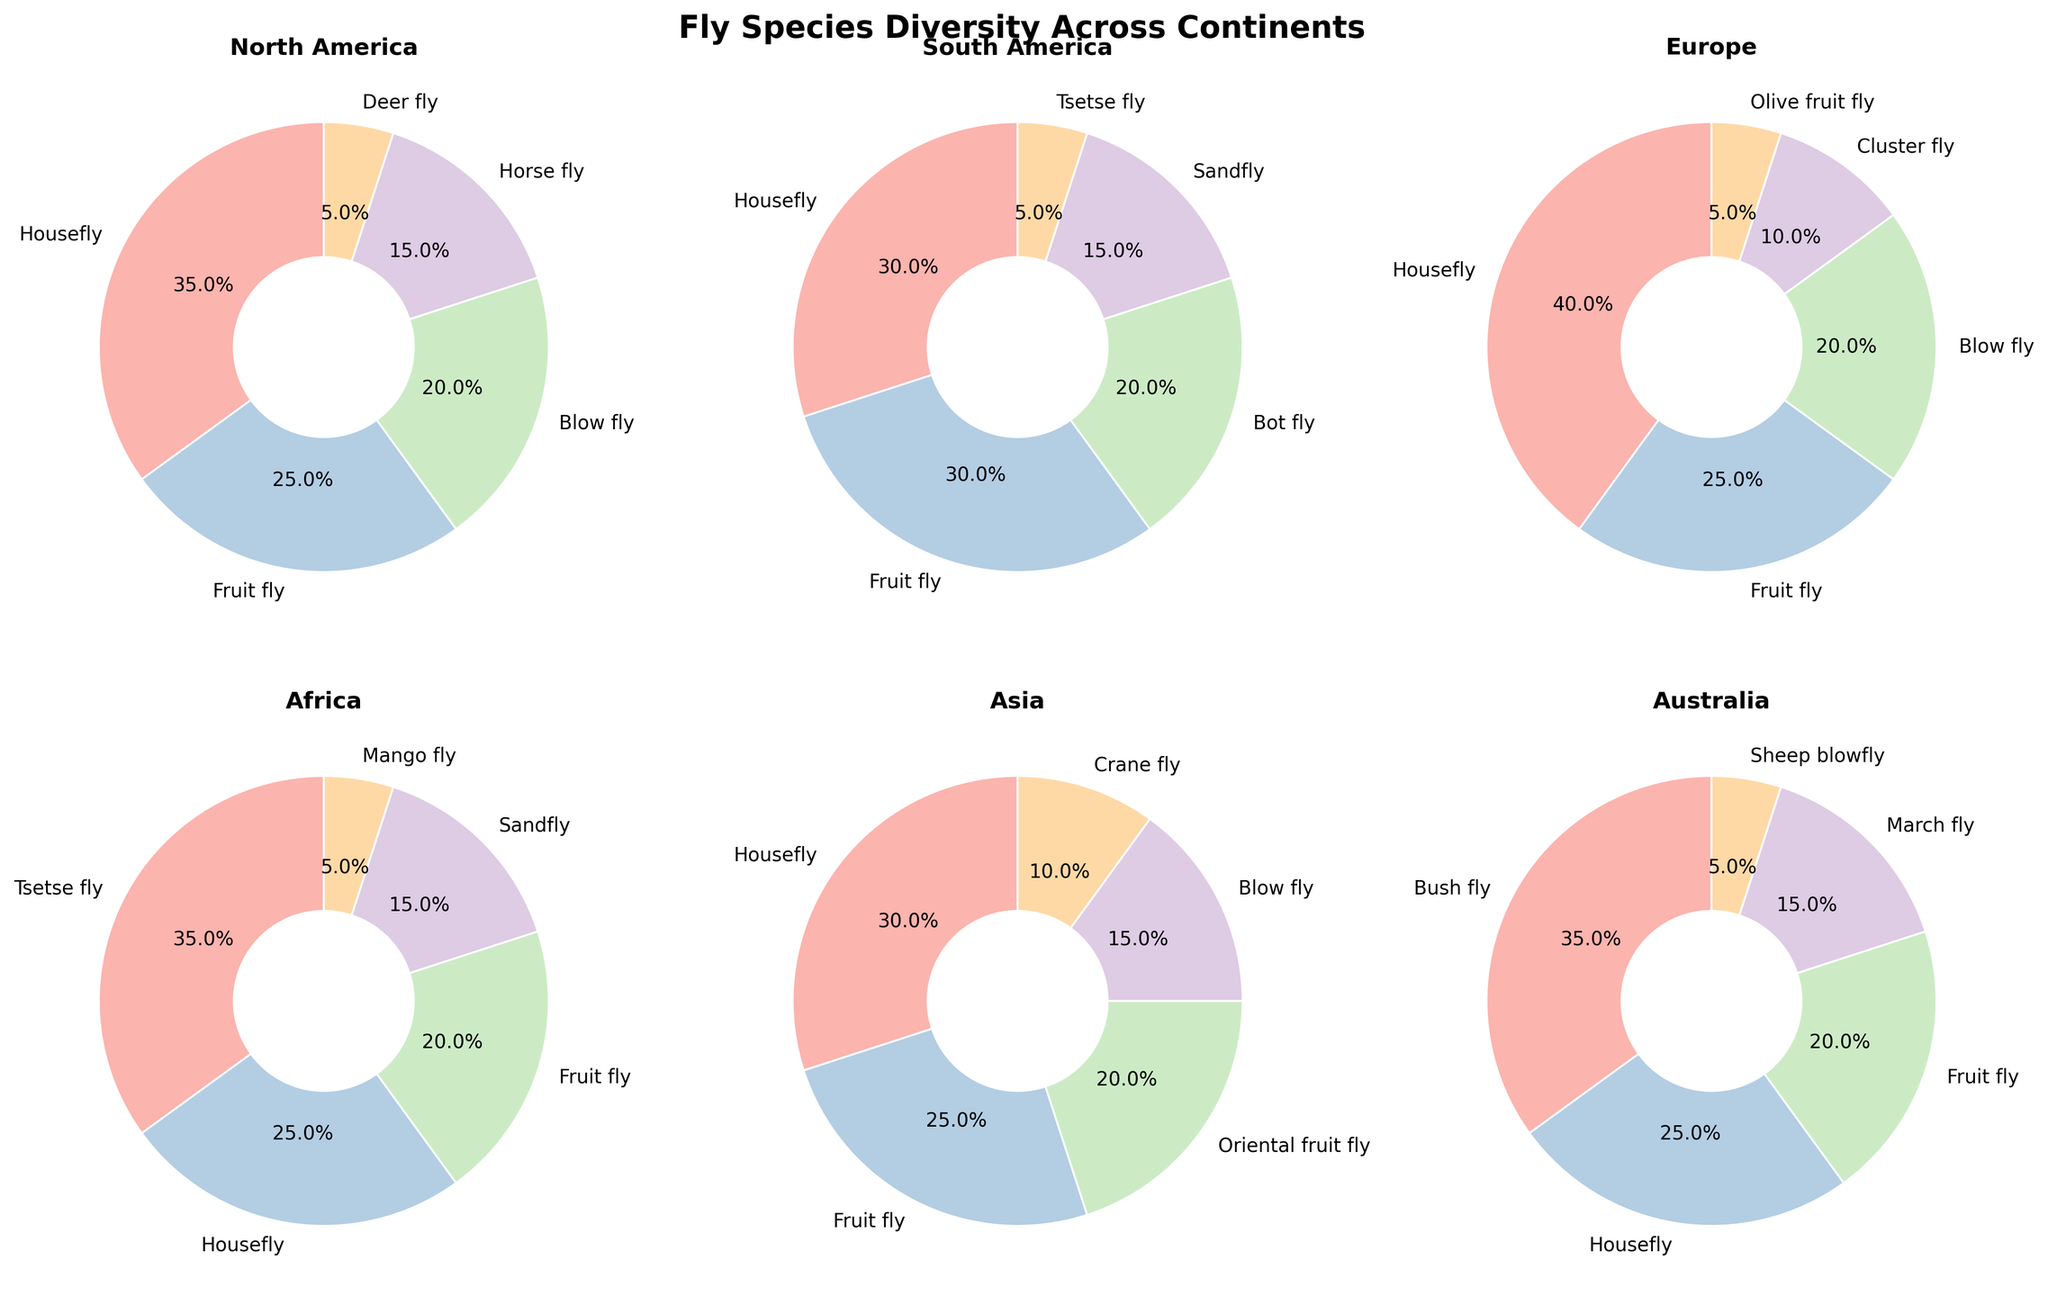what percentage of flies are houseflies in North America? According to the pie chart for North America, houseflies make up 35% of the total fly species.
Answer: 35% Which continent has the highest percentage of tsetse flies? Looking at the segment representing tsetse flies in each continent, Africa has the highest percentage at 35%.
Answer: Africa What is the difference in the percentage of houseflies between Europe and Asia? The pie charts show that Europe has 40% houseflies, and Asia has 30%. The difference is 40% - 30% = 10%.
Answer: 10% Which continent has the most diverse range of fly species? From the figure, North America and South America both have five different fly species represented, which are the highest among all continents.
Answer: North America and South America How many total species cover more than 20% in their respective continents? By counting the species that cover more than 20%:
- North America: Housefly (35%), Fruit fly (25%), Blow fly (20%)
- South America: Housefly (30%), Fruit fly (30%)
- Europe: Housefly (40%), Fruit fly (25%), Blow fly (20%)
- Africa: Tsetse fly (35%), Housefly (25%), Fruit fly (20%)
- Asia: Housefly (30%), Fruit fly (25%), Oriental fruit fly (20%)
- Australia: Bush fly (35%), Housefly (25%), Fruit fly (20%)
 This gives us a total of 14 species.
Answer: 14 Which continent has the largest share of fruit flies? Comparing the percentage segments for fruit flies in each continent, South America and Europe both have 30% fruit flies, which are the highest.
Answer: South America and Europe What is the combined percentage of houseflies and fruit flies in Asia? The pie chart shows that houseflies make up 30% and fruit flies make up 25% in Asia. The combined percentage is 30% + 25% = 55%.
Answer: 55% In which continent does the blow fly have the highest percentage? The blow fly percentage is provided in the pie charts; North America and Europe have 20% each.
Answer: North America and Europe How does the percentage of sandflies in South America compare to that in Africa? The sandfly percentage is 15% in both South America and Africa. Therefore, they are equal.
Answer: Equal 